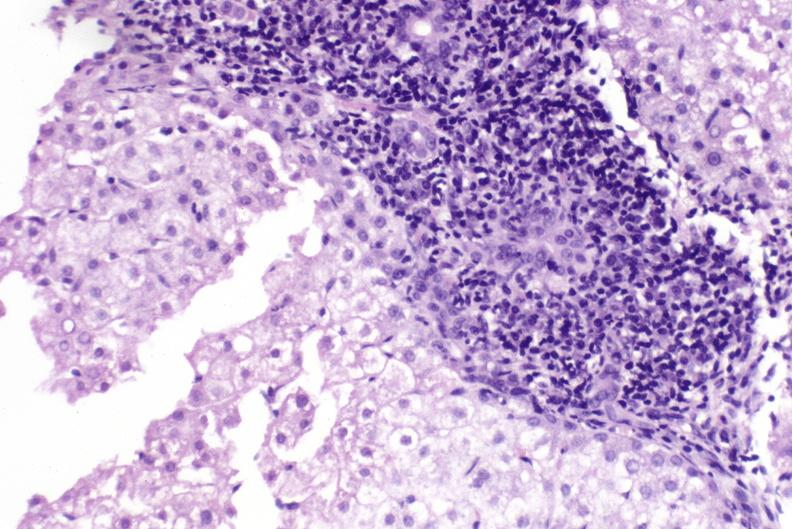s pierre robin sndrome present?
Answer the question using a single word or phrase. No 